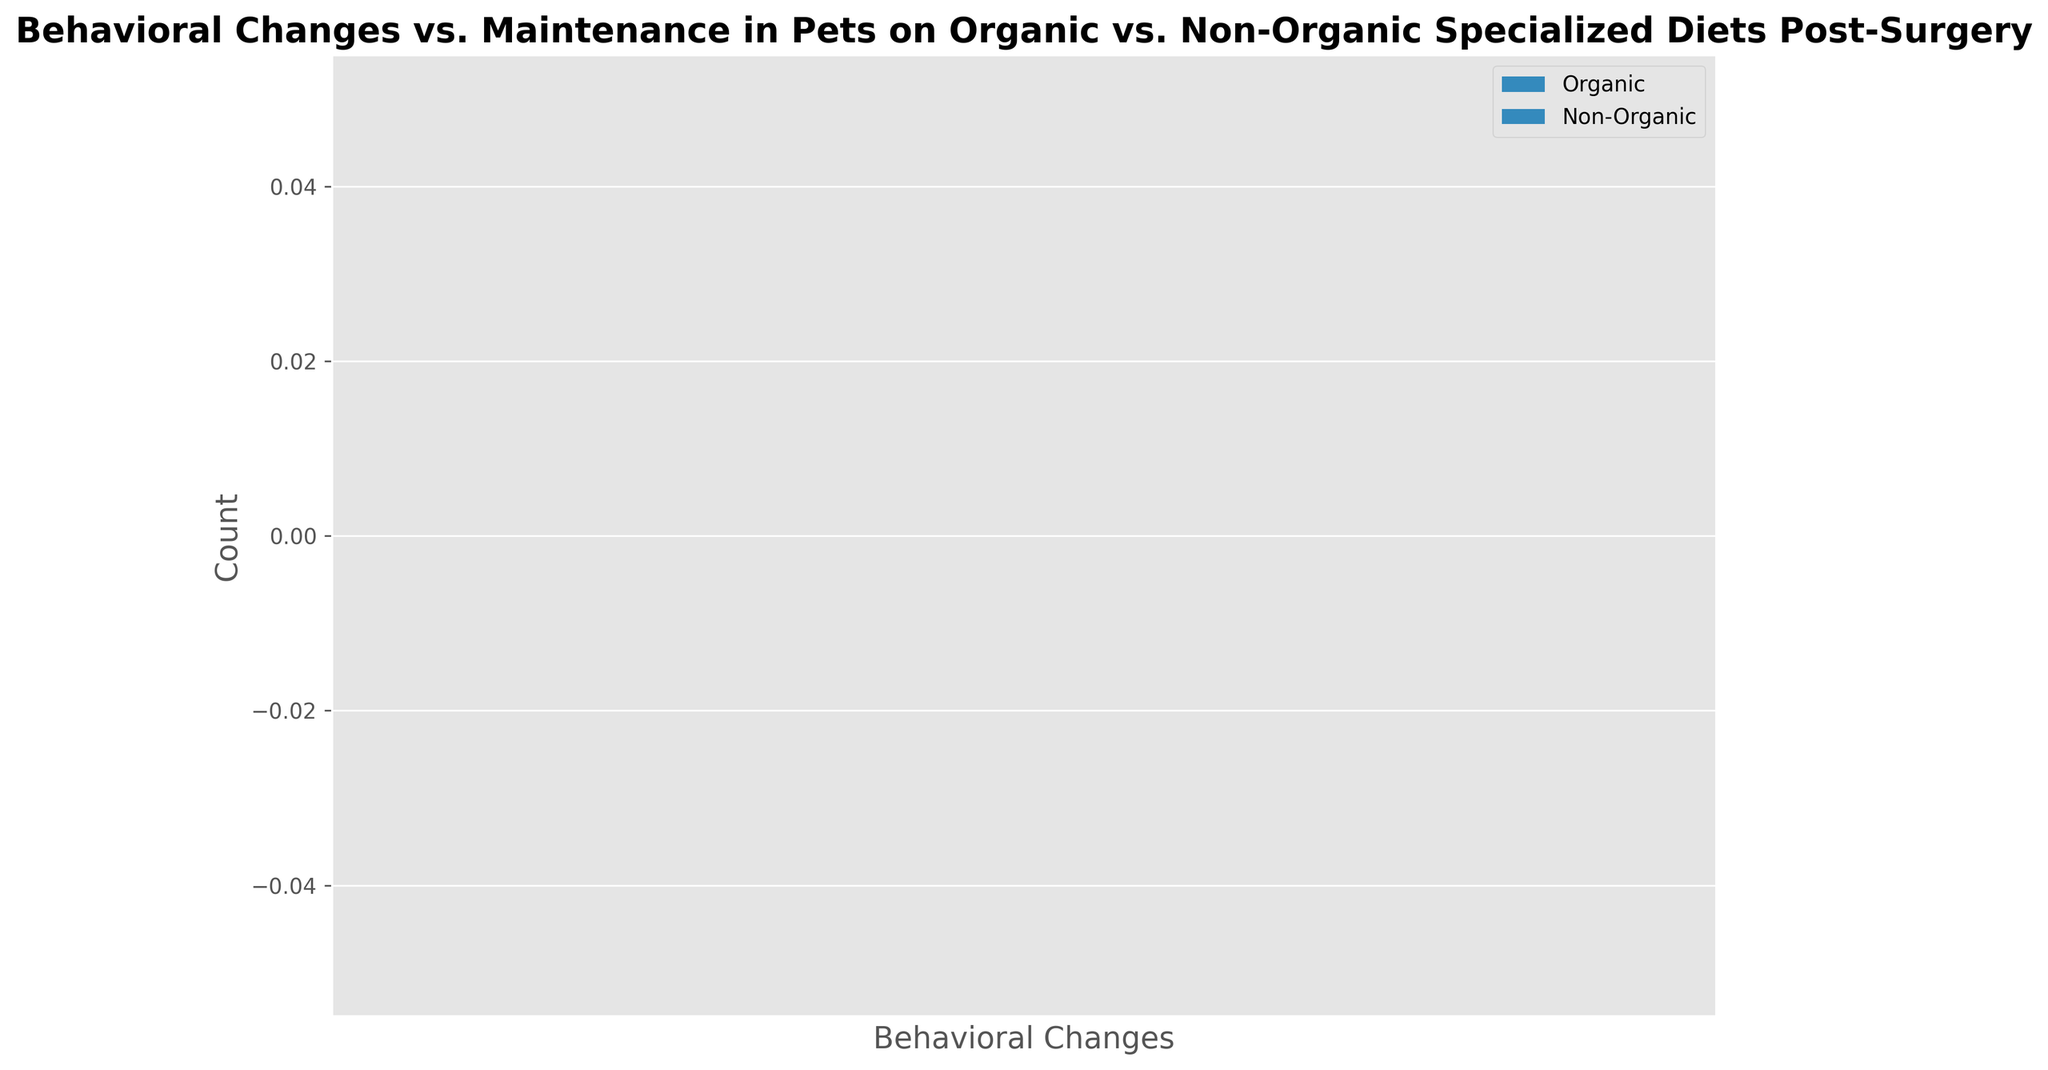What is the total count of positive behavioral changes in pets on an organic diet? Sum the counts associated with positive behavioral changes for the organic diet: Increased Activity (25), Improved Appetite (28), Reduced Anxiety (15). So, 25 + 28 + 15 = 68
Answer: 68 Which diet type has a higher number of pets with increased aggression? Compare the bar heights (counts) for increased aggression: Organic (5) vs. Non-Organic (10). Since 10 is greater than 5, the Non-Organic diet has a higher number of pets with increased aggression
Answer: Non-Organic What is the difference in the number of pets with improved appetite between the organic and non-organic diets? Subtract the count for non-organic pets with improved appetite from the count for organic pets with improved appetite: 28 - 22 = 6
Answer: 6 Which behavioral change has the highest count among pets on a non-organic diet? Look at the bar heights for non-organic diet categories and identify the highest: Improved Appetite (22) is the highest among non-organic categories
Answer: Improved Appetite How many more pets on a non-organic diet experienced digestive issues compared to those on an organic diet? Subtract the count for the organic diet from the non-organic diet for digestive issues: 8 - 4 = 4
Answer: 4 How many behaviors show higher negative changes for non-organic diet compared to those for organic diet? Compare counts for behaviors with negative changes: Increased Aggression (Non-Organic 10 > Organic 5), Digestive Issues (Non-Organic 8 > Organic 4). Both behaviors show higher for non-organic diets, count = 2
Answer: 2 What is the total difference in counts for positive behavioral changes between organic and non-organic diets? Calculate the sum of counts for positive changes in both diets and subtract: 
Organic (25 + 28 + 15) = 68, Non-Organic (20 + 22 + 10) = 52, Difference = 68 - 52 = 16
Answer: 16 Is there any behavioral change where the count is the same for both organic and non-organic diets? Check all categories in the chart: no two bars have the same height for organic and non-organic diet comparisons
Answer: No Which negative behavioral change is more prevalent in non-organic diet pets than in organic diet pets? Compare the counts for negative changes: Increased Aggression (Non-Organic 10 > Organic 5), Digestive Issues (Non-Organic 8 > Organic 4). Increased Aggression is more prevalent
Answer: Increased Aggression 